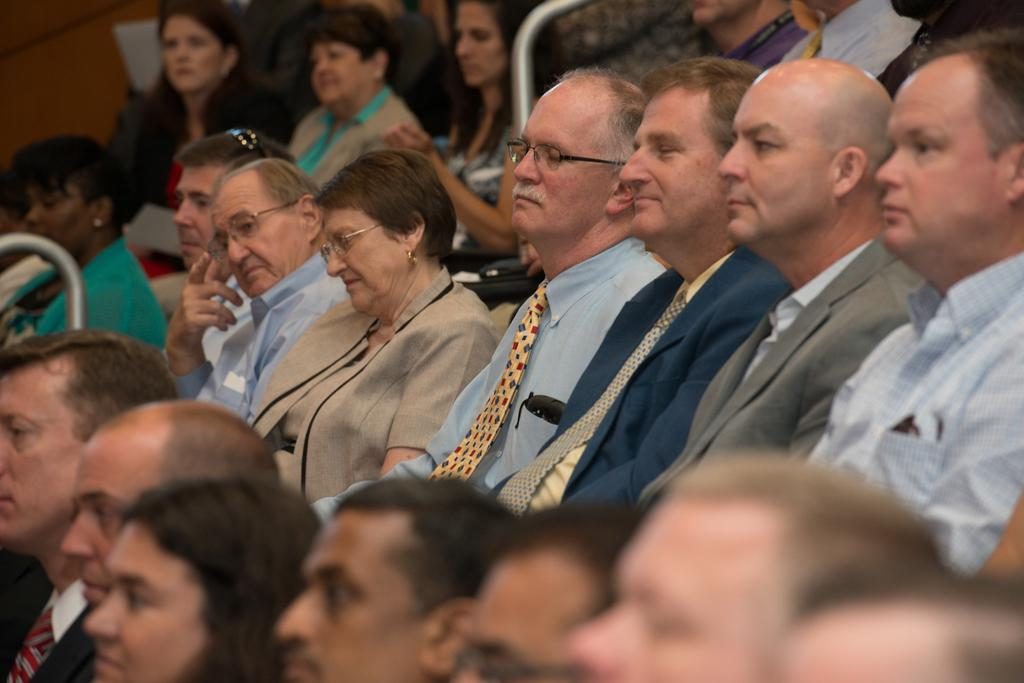What are the people in the image doing? The people in the image are sitting. Can you describe the appearance of the three persons in the middle? The three persons in the middle are wearing spectacles. What objects can be seen in the middle of the image? There are two metal rods in the middle of the image. What type of peace symbol can be seen on the seashore in the image? There is no seashore or peace symbol present in the image. What boundary is visible between the two metal rods in the image? There is no boundary visible between the two metal rods in the image; they are simply two separate objects. 